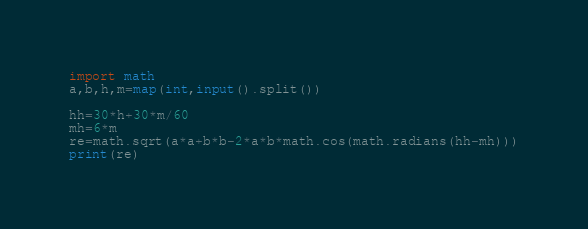<code> <loc_0><loc_0><loc_500><loc_500><_Python_>import math
a,b,h,m=map(int,input().split())

hh=30*h+30*m/60
mh=6*m
re=math.sqrt(a*a+b*b-2*a*b*math.cos(math.radians(hh-mh)))
print(re)</code> 